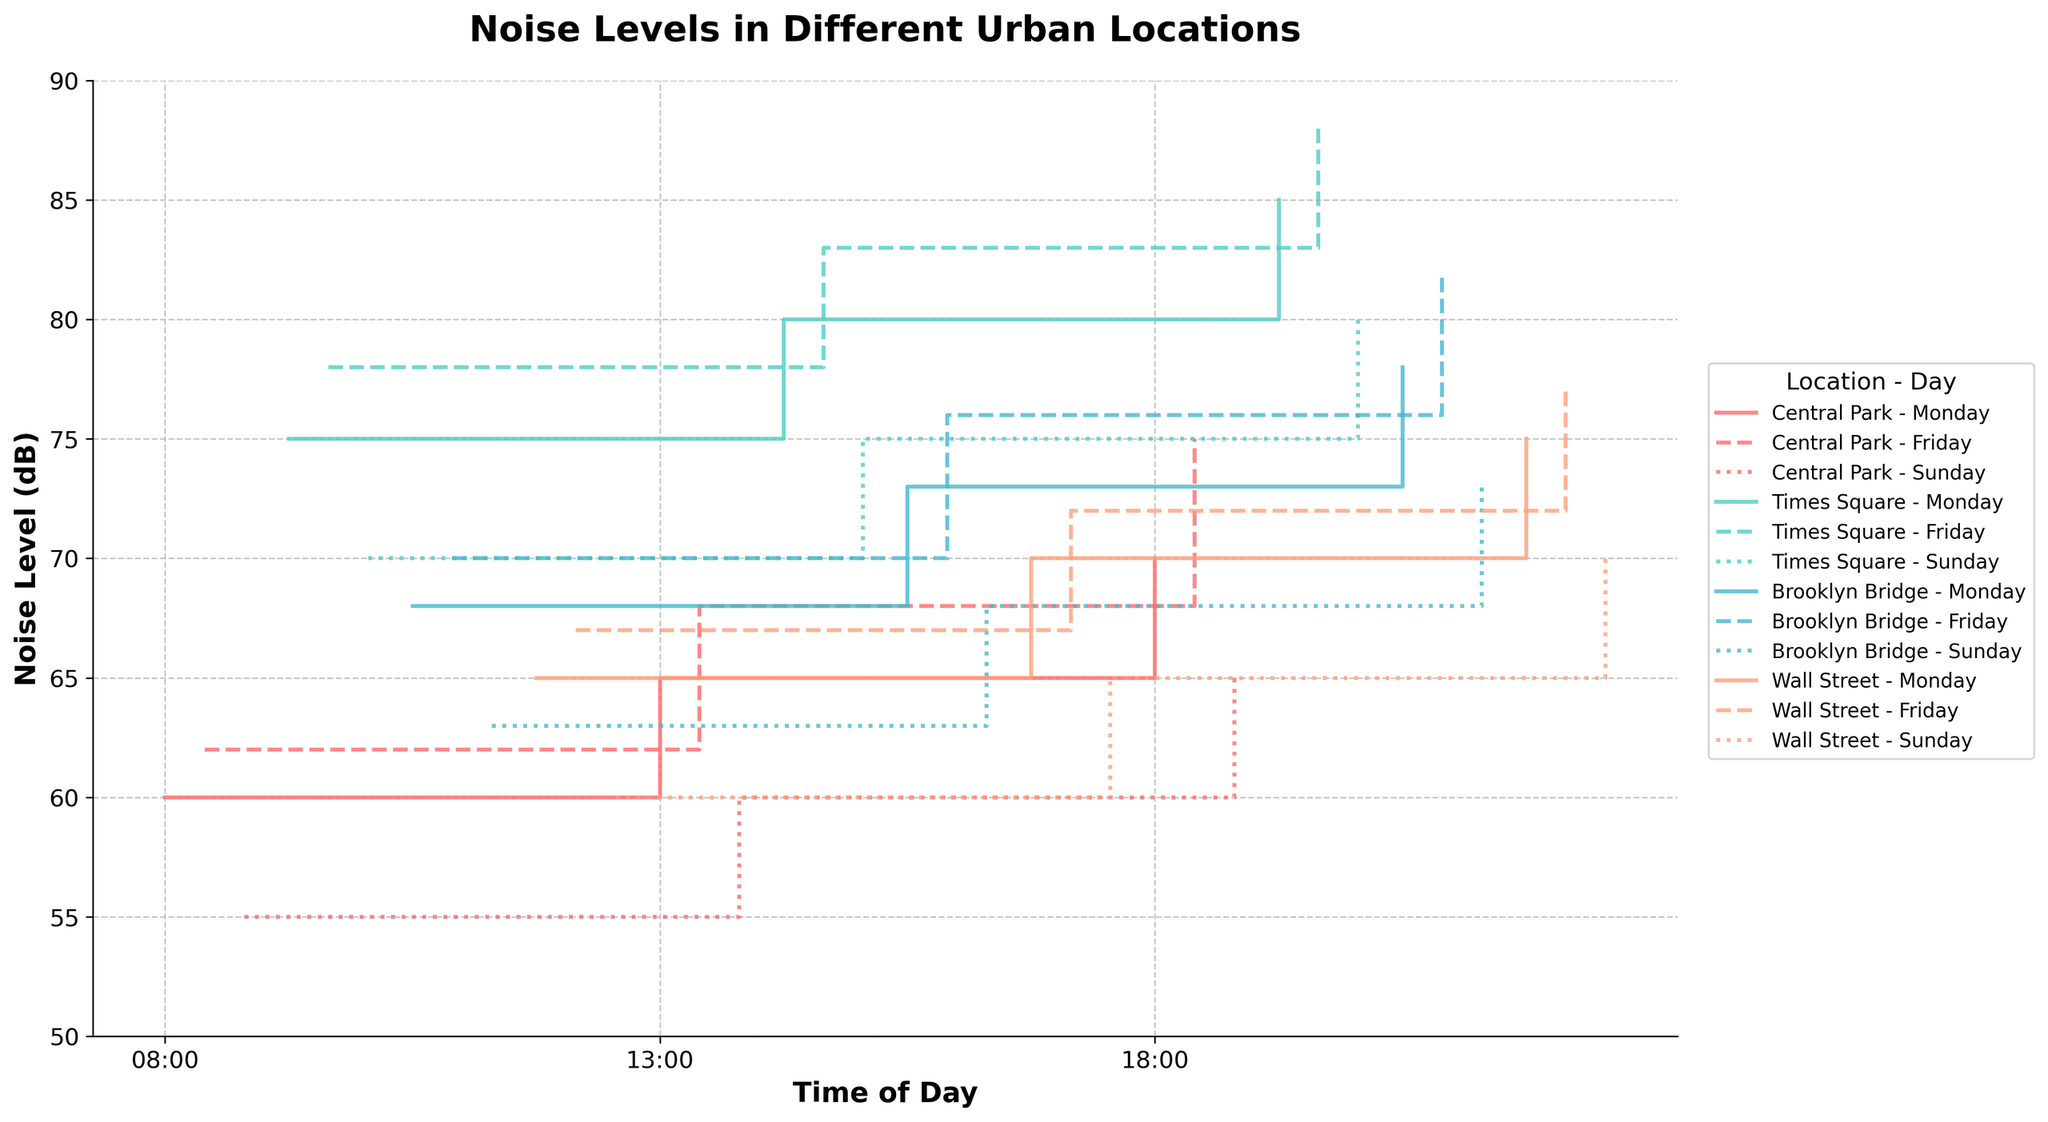How many locations are represented in the figure? The four locations labeled in the legend of the figure are Central Park, Times Square, Brooklyn Bridge, and Wall Street.
Answer: 4 Which time of day generally shows the highest noise levels across all locations? By observing the step values at 08:00, 13:00, and 18:00 across all locations, we see that the noise levels are highest at 18:00.
Answer: 18:00 What is the noise level at Central Park at 08:00 on Monday? From the labeled steps, the noise level at Central Park at 08:00 on Monday is indicated to be 60 dB.
Answer: 60 dB On which day is the noise level at Times Square at 18:00 the highest? Comparing the step values for Times Square at 18:00 across Monday, Friday, and Sunday, the highest noise level is 88 dB on Friday.
Answer: Friday How does the noise level at Wall Street at 08:00 on Sunday compare to Wall Street at 18:00 on Sunday? To compare, the noise level at Wall Street at 08:00 on Sunday is 60 dB and at 18:00 on Sunday is 70 dB, showing an increase of 10 dB by 18:00.
Answer: 70 dB is higher Between which time intervals does Times Square experience the largest increase in noise level on Monday? By observing the step changes, the noise level at Times Square increases the most between 08:00 (75 dB) and 13:00 (80 dB), showing an increase of 5 dB.
Answer: 08:00 to 13:00 What is the trend in noise levels at Brooklyn Bridge from 08:00 to 18:00 on Friday? Reviewing the step data for Brooklyn Bridge on Friday, the noise level increases from 70 dB at 08:00 to 76 dB at 13:00 and further up to 82 dB at 18:00, indicating a rising trend throughout the day.
Answer: Rising Which location shows the greatest variation in noise levels throughout the week at 18:00? By checking the values at 18:00 for each day at all locations, Times Square shows the greatest variation in noise levels ranging from 65 dB on Sunday to 88 dB on Friday.
Answer: Times Square What are the average noise levels for Central Park on Monday? The noise levels for Central Park on Monday are 60 dB (08:00), 65 dB (13:00), and 70 dB (18:00). The sum is 195 dB, so the average is 195/3 = 65 dB.
Answer: 65 dB 